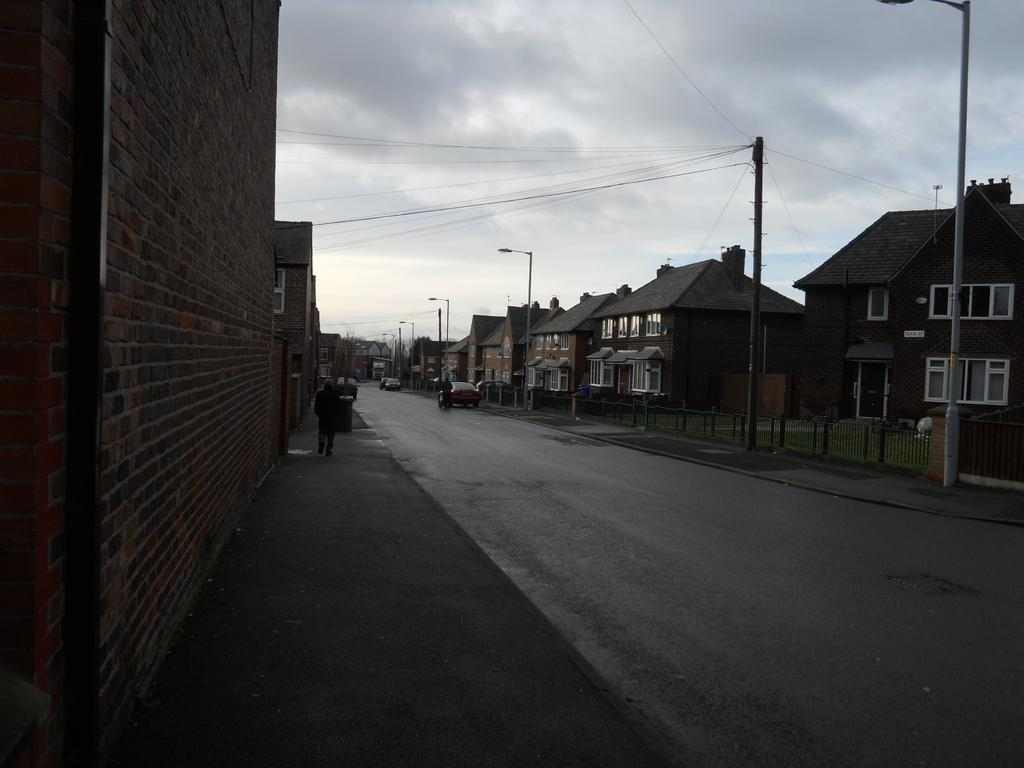What is the main feature of the image? There is a road in the image. What else can be seen on the road? There are vehicles in the image. What are the poles in the image used for? The poles in the image are likely used for supporting wires. Can you describe the people in the image? There are people in the image, but their specific actions or appearances are not mentioned in the facts. What type of structures can be seen in the image? There are houses in the image. What is visible in the background of the image? The sky is visible in the background of the image, and there are clouds in the sky. What type of company is represented by the jelly on the road in the image? There is no jelly present in the image, so it is not possible to determine any company representation. 